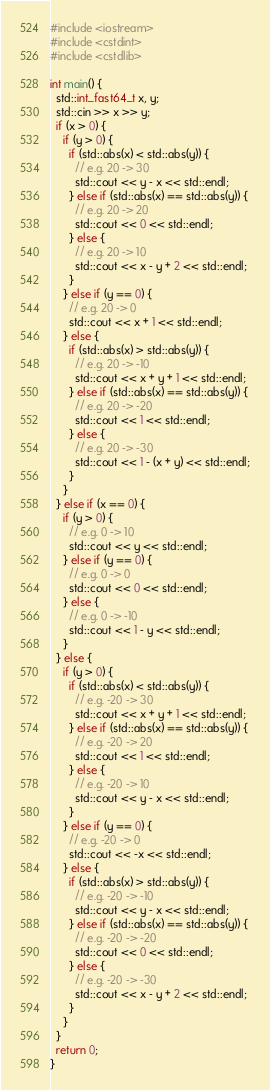<code> <loc_0><loc_0><loc_500><loc_500><_C++_>#include <iostream>
#include <cstdint>
#include <cstdlib>

int main() {
  std::int_fast64_t x, y;
  std::cin >> x >> y;
  if (x > 0) {
    if (y > 0) {
      if (std::abs(x) < std::abs(y)) {
        // e.g. 20 -> 30
        std::cout << y - x << std::endl;
      } else if (std::abs(x) == std::abs(y)) {
        // e.g. 20 -> 20
        std::cout << 0 << std::endl;
      } else {
        // e.g. 20 -> 10
        std::cout << x - y + 2 << std::endl;
      }
    } else if (y == 0) {
      // e.g. 20 -> 0
      std::cout << x + 1 << std::endl;
    } else {
      if (std::abs(x) > std::abs(y)) {
        // e.g. 20 -> -10
        std::cout << x + y + 1 << std::endl;
      } else if (std::abs(x) == std::abs(y)) {
        // e.g. 20 -> -20
        std::cout << 1 << std::endl;
      } else {
        // e.g. 20 -> -30
        std::cout << 1 - (x + y) << std::endl;
      }
    }
  } else if (x == 0) {
    if (y > 0) {
      // e.g. 0 -> 10
      std::cout << y << std::endl;
    } else if (y == 0) {
      // e.g. 0 -> 0
      std::cout << 0 << std::endl;
    } else {
      // e.g. 0 -> -10
      std::cout << 1 - y << std::endl;
    }
  } else {
    if (y > 0) {
      if (std::abs(x) < std::abs(y)) {
        // e.g. -20 -> 30
        std::cout << x + y + 1 << std::endl;
      } else if (std::abs(x) == std::abs(y)) {
        // e.g. -20 -> 20
        std::cout << 1 << std::endl;
      } else {
        // e.g. -20 -> 10
        std::cout << y - x << std::endl;
      }
    } else if (y == 0) {
      // e.g. -20 -> 0
      std::cout << -x << std::endl;
    } else {
      if (std::abs(x) > std::abs(y)) {
        // e.g. -20 -> -10
        std::cout << y - x << std::endl;
      } else if (std::abs(x) == std::abs(y)) {
        // e.g. -20 -> -20
        std::cout << 0 << std::endl;
      } else {
        // e.g. -20 -> -30
        std::cout << x - y + 2 << std::endl;
      }
    }
  }
  return 0;
}</code> 